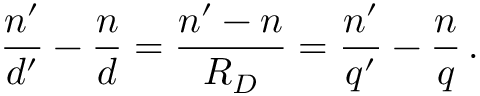<formula> <loc_0><loc_0><loc_500><loc_500>{ \frac { n ^ { \prime } } { d ^ { \prime } } } - { \frac { n } { d } } = { \frac { n ^ { \prime } - n } { R _ { D } } } = { \frac { n ^ { \prime } } { q ^ { \prime } } } - { \frac { n } { q } } \, .</formula> 